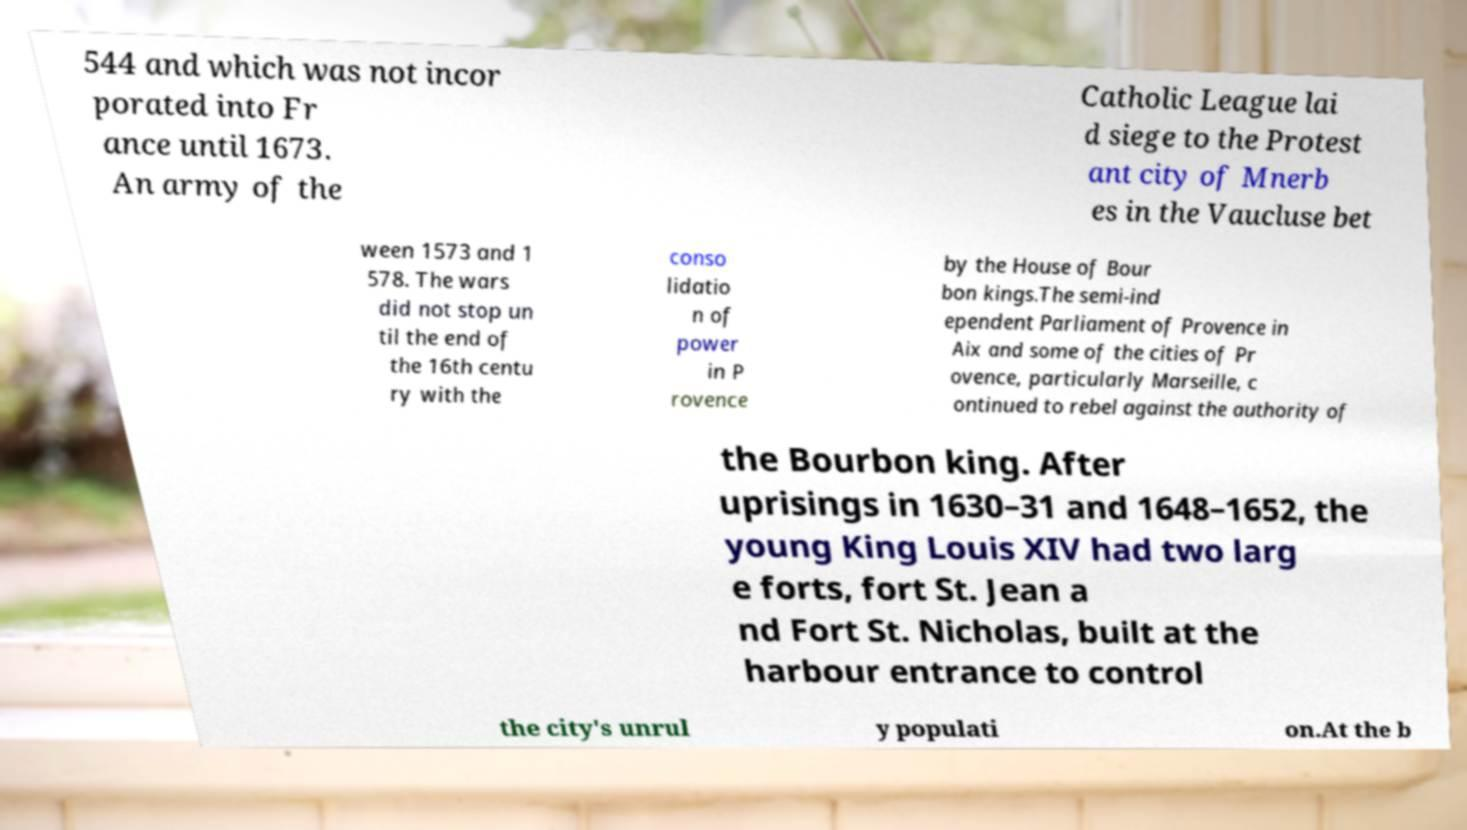Can you accurately transcribe the text from the provided image for me? 544 and which was not incor porated into Fr ance until 1673. An army of the Catholic League lai d siege to the Protest ant city of Mnerb es in the Vaucluse bet ween 1573 and 1 578. The wars did not stop un til the end of the 16th centu ry with the conso lidatio n of power in P rovence by the House of Bour bon kings.The semi-ind ependent Parliament of Provence in Aix and some of the cities of Pr ovence, particularly Marseille, c ontinued to rebel against the authority of the Bourbon king. After uprisings in 1630–31 and 1648–1652, the young King Louis XIV had two larg e forts, fort St. Jean a nd Fort St. Nicholas, built at the harbour entrance to control the city's unrul y populati on.At the b 